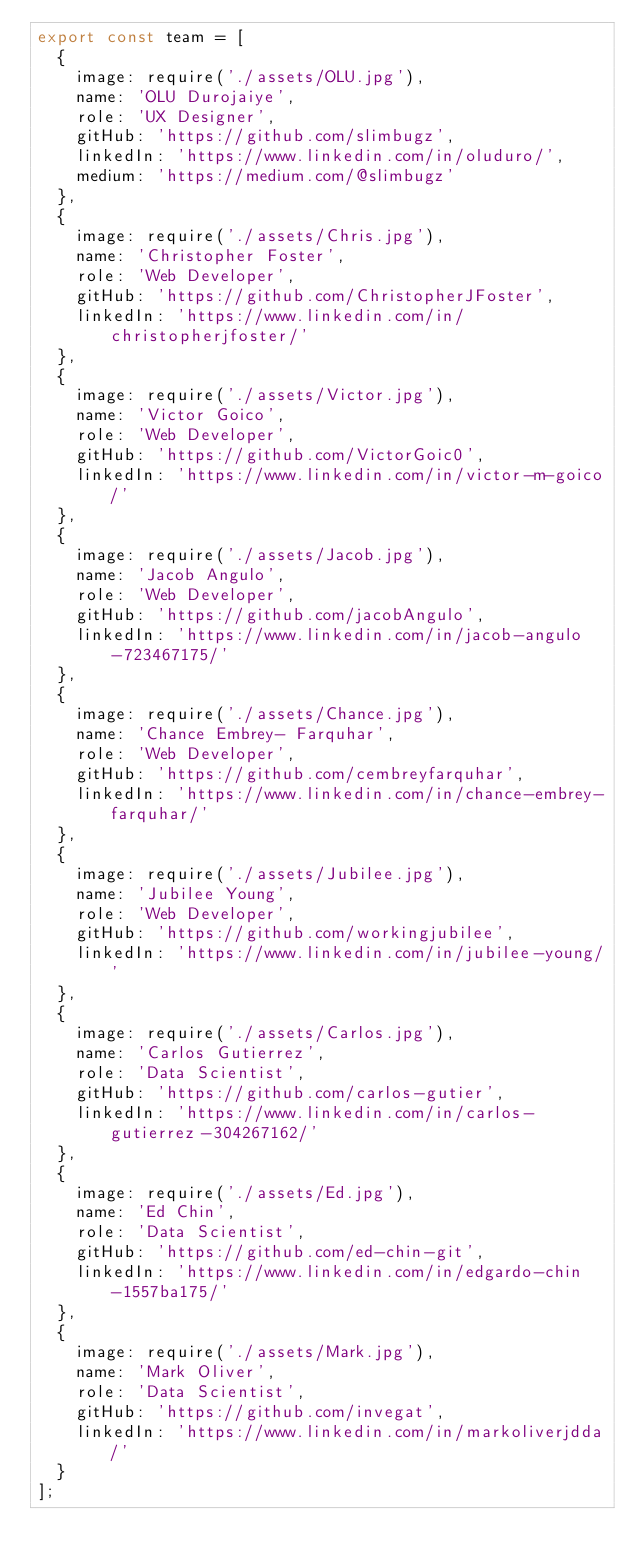<code> <loc_0><loc_0><loc_500><loc_500><_JavaScript_>export const team = [
  {
    image: require('./assets/OLU.jpg'),
    name: 'OLU Durojaiye',
    role: 'UX Designer',
    gitHub: 'https://github.com/slimbugz',
    linkedIn: 'https://www.linkedin.com/in/oluduro/',
    medium: 'https://medium.com/@slimbugz'
  },
  {
    image: require('./assets/Chris.jpg'),
    name: 'Christopher Foster',
    role: 'Web Developer',
    gitHub: 'https://github.com/ChristopherJFoster',
    linkedIn: 'https://www.linkedin.com/in/christopherjfoster/'
  },
  {
    image: require('./assets/Victor.jpg'),
    name: 'Victor Goico',
    role: 'Web Developer',
    gitHub: 'https://github.com/VictorGoic0',
    linkedIn: 'https://www.linkedin.com/in/victor-m-goico/'
  },
  {
    image: require('./assets/Jacob.jpg'),
    name: 'Jacob Angulo',
    role: 'Web Developer',
    gitHub: 'https://github.com/jacobAngulo',
    linkedIn: 'https://www.linkedin.com/in/jacob-angulo-723467175/'
  },
  {
    image: require('./assets/Chance.jpg'),
    name: 'Chance Embrey- Farquhar',
    role: 'Web Developer',
    gitHub: 'https://github.com/cembreyfarquhar',
    linkedIn: 'https://www.linkedin.com/in/chance-embrey-farquhar/'
  },
  {
    image: require('./assets/Jubilee.jpg'),
    name: 'Jubilee Young',
    role: 'Web Developer',
    gitHub: 'https://github.com/workingjubilee',
    linkedIn: 'https://www.linkedin.com/in/jubilee-young/'
  },
  {
    image: require('./assets/Carlos.jpg'),
    name: 'Carlos Gutierrez',
    role: 'Data Scientist',
    gitHub: 'https://github.com/carlos-gutier',
    linkedIn: 'https://www.linkedin.com/in/carlos-gutierrez-304267162/'
  },
  {
    image: require('./assets/Ed.jpg'),
    name: 'Ed Chin',
    role: 'Data Scientist',
    gitHub: 'https://github.com/ed-chin-git',
    linkedIn: 'https://www.linkedin.com/in/edgardo-chin-1557ba175/'
  },
  {
    image: require('./assets/Mark.jpg'),
    name: 'Mark Oliver',
    role: 'Data Scientist',
    gitHub: 'https://github.com/invegat',
    linkedIn: 'https://www.linkedin.com/in/markoliverjdda/'
  }
];
</code> 